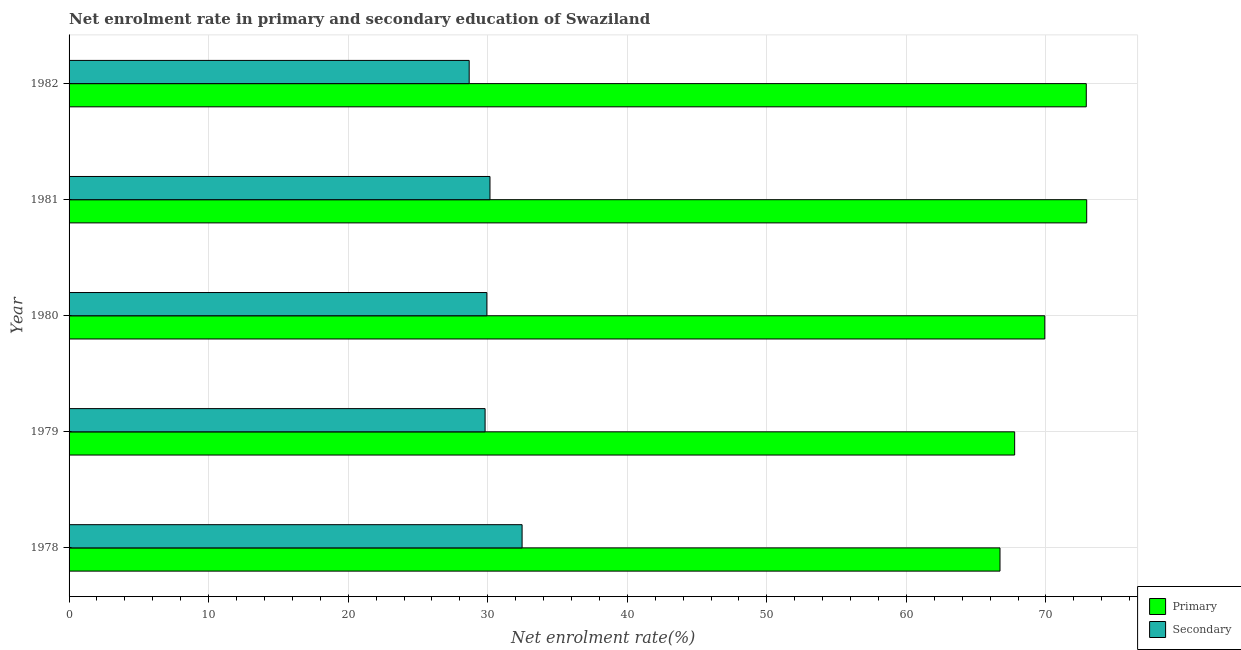Are the number of bars per tick equal to the number of legend labels?
Ensure brevity in your answer.  Yes. How many bars are there on the 5th tick from the top?
Provide a succinct answer. 2. How many bars are there on the 4th tick from the bottom?
Provide a succinct answer. 2. In how many cases, is the number of bars for a given year not equal to the number of legend labels?
Your response must be concise. 0. What is the enrollment rate in secondary education in 1982?
Provide a short and direct response. 28.67. Across all years, what is the maximum enrollment rate in secondary education?
Keep it short and to the point. 32.46. Across all years, what is the minimum enrollment rate in primary education?
Offer a terse response. 66.71. In which year was the enrollment rate in secondary education maximum?
Offer a terse response. 1978. In which year was the enrollment rate in primary education minimum?
Your answer should be very brief. 1978. What is the total enrollment rate in primary education in the graph?
Provide a short and direct response. 350.19. What is the difference between the enrollment rate in primary education in 1978 and that in 1982?
Offer a terse response. -6.18. What is the difference between the enrollment rate in primary education in 1981 and the enrollment rate in secondary education in 1978?
Make the answer very short. 40.46. What is the average enrollment rate in secondary education per year?
Give a very brief answer. 30.21. In the year 1978, what is the difference between the enrollment rate in secondary education and enrollment rate in primary education?
Your answer should be compact. -34.24. In how many years, is the enrollment rate in secondary education greater than 8 %?
Your response must be concise. 5. What is the difference between the highest and the second highest enrollment rate in secondary education?
Keep it short and to the point. 2.3. What is the difference between the highest and the lowest enrollment rate in secondary education?
Provide a succinct answer. 3.79. Is the sum of the enrollment rate in primary education in 1978 and 1979 greater than the maximum enrollment rate in secondary education across all years?
Ensure brevity in your answer.  Yes. What does the 1st bar from the top in 1979 represents?
Offer a terse response. Secondary. What does the 1st bar from the bottom in 1978 represents?
Keep it short and to the point. Primary. How many bars are there?
Keep it short and to the point. 10. Are all the bars in the graph horizontal?
Make the answer very short. Yes. How many years are there in the graph?
Offer a very short reply. 5. Are the values on the major ticks of X-axis written in scientific E-notation?
Your answer should be compact. No. How many legend labels are there?
Ensure brevity in your answer.  2. What is the title of the graph?
Keep it short and to the point. Net enrolment rate in primary and secondary education of Swaziland. Does "Rural Population" appear as one of the legend labels in the graph?
Ensure brevity in your answer.  No. What is the label or title of the X-axis?
Your answer should be compact. Net enrolment rate(%). What is the Net enrolment rate(%) of Primary in 1978?
Make the answer very short. 66.71. What is the Net enrolment rate(%) of Secondary in 1978?
Your answer should be very brief. 32.46. What is the Net enrolment rate(%) in Primary in 1979?
Keep it short and to the point. 67.76. What is the Net enrolment rate(%) of Secondary in 1979?
Provide a short and direct response. 29.81. What is the Net enrolment rate(%) in Primary in 1980?
Your response must be concise. 69.92. What is the Net enrolment rate(%) in Secondary in 1980?
Provide a succinct answer. 29.94. What is the Net enrolment rate(%) in Primary in 1981?
Offer a terse response. 72.92. What is the Net enrolment rate(%) in Secondary in 1981?
Give a very brief answer. 30.16. What is the Net enrolment rate(%) in Primary in 1982?
Give a very brief answer. 72.89. What is the Net enrolment rate(%) in Secondary in 1982?
Ensure brevity in your answer.  28.67. Across all years, what is the maximum Net enrolment rate(%) in Primary?
Keep it short and to the point. 72.92. Across all years, what is the maximum Net enrolment rate(%) of Secondary?
Offer a terse response. 32.46. Across all years, what is the minimum Net enrolment rate(%) in Primary?
Make the answer very short. 66.71. Across all years, what is the minimum Net enrolment rate(%) in Secondary?
Provide a succinct answer. 28.67. What is the total Net enrolment rate(%) of Primary in the graph?
Provide a succinct answer. 350.19. What is the total Net enrolment rate(%) in Secondary in the graph?
Make the answer very short. 151.04. What is the difference between the Net enrolment rate(%) in Primary in 1978 and that in 1979?
Offer a very short reply. -1.05. What is the difference between the Net enrolment rate(%) of Secondary in 1978 and that in 1979?
Make the answer very short. 2.65. What is the difference between the Net enrolment rate(%) in Primary in 1978 and that in 1980?
Ensure brevity in your answer.  -3.21. What is the difference between the Net enrolment rate(%) of Secondary in 1978 and that in 1980?
Offer a terse response. 2.52. What is the difference between the Net enrolment rate(%) of Primary in 1978 and that in 1981?
Offer a terse response. -6.21. What is the difference between the Net enrolment rate(%) of Secondary in 1978 and that in 1981?
Offer a terse response. 2.3. What is the difference between the Net enrolment rate(%) in Primary in 1978 and that in 1982?
Offer a very short reply. -6.18. What is the difference between the Net enrolment rate(%) in Secondary in 1978 and that in 1982?
Your answer should be very brief. 3.79. What is the difference between the Net enrolment rate(%) in Primary in 1979 and that in 1980?
Offer a terse response. -2.16. What is the difference between the Net enrolment rate(%) of Secondary in 1979 and that in 1980?
Provide a succinct answer. -0.13. What is the difference between the Net enrolment rate(%) of Primary in 1979 and that in 1981?
Your answer should be very brief. -5.16. What is the difference between the Net enrolment rate(%) in Secondary in 1979 and that in 1981?
Provide a succinct answer. -0.35. What is the difference between the Net enrolment rate(%) in Primary in 1979 and that in 1982?
Keep it short and to the point. -5.13. What is the difference between the Net enrolment rate(%) of Secondary in 1979 and that in 1982?
Ensure brevity in your answer.  1.14. What is the difference between the Net enrolment rate(%) of Primary in 1980 and that in 1981?
Make the answer very short. -3. What is the difference between the Net enrolment rate(%) of Secondary in 1980 and that in 1981?
Ensure brevity in your answer.  -0.22. What is the difference between the Net enrolment rate(%) of Primary in 1980 and that in 1982?
Your response must be concise. -2.97. What is the difference between the Net enrolment rate(%) in Secondary in 1980 and that in 1982?
Provide a succinct answer. 1.27. What is the difference between the Net enrolment rate(%) of Primary in 1981 and that in 1982?
Offer a terse response. 0.03. What is the difference between the Net enrolment rate(%) in Secondary in 1981 and that in 1982?
Your answer should be compact. 1.49. What is the difference between the Net enrolment rate(%) of Primary in 1978 and the Net enrolment rate(%) of Secondary in 1979?
Provide a short and direct response. 36.9. What is the difference between the Net enrolment rate(%) of Primary in 1978 and the Net enrolment rate(%) of Secondary in 1980?
Your answer should be very brief. 36.77. What is the difference between the Net enrolment rate(%) of Primary in 1978 and the Net enrolment rate(%) of Secondary in 1981?
Give a very brief answer. 36.55. What is the difference between the Net enrolment rate(%) of Primary in 1978 and the Net enrolment rate(%) of Secondary in 1982?
Give a very brief answer. 38.04. What is the difference between the Net enrolment rate(%) of Primary in 1979 and the Net enrolment rate(%) of Secondary in 1980?
Make the answer very short. 37.82. What is the difference between the Net enrolment rate(%) in Primary in 1979 and the Net enrolment rate(%) in Secondary in 1981?
Provide a succinct answer. 37.6. What is the difference between the Net enrolment rate(%) of Primary in 1979 and the Net enrolment rate(%) of Secondary in 1982?
Provide a succinct answer. 39.09. What is the difference between the Net enrolment rate(%) in Primary in 1980 and the Net enrolment rate(%) in Secondary in 1981?
Make the answer very short. 39.76. What is the difference between the Net enrolment rate(%) of Primary in 1980 and the Net enrolment rate(%) of Secondary in 1982?
Provide a succinct answer. 41.25. What is the difference between the Net enrolment rate(%) in Primary in 1981 and the Net enrolment rate(%) in Secondary in 1982?
Ensure brevity in your answer.  44.25. What is the average Net enrolment rate(%) of Primary per year?
Make the answer very short. 70.04. What is the average Net enrolment rate(%) of Secondary per year?
Provide a short and direct response. 30.21. In the year 1978, what is the difference between the Net enrolment rate(%) in Primary and Net enrolment rate(%) in Secondary?
Keep it short and to the point. 34.24. In the year 1979, what is the difference between the Net enrolment rate(%) in Primary and Net enrolment rate(%) in Secondary?
Provide a succinct answer. 37.94. In the year 1980, what is the difference between the Net enrolment rate(%) in Primary and Net enrolment rate(%) in Secondary?
Your response must be concise. 39.98. In the year 1981, what is the difference between the Net enrolment rate(%) of Primary and Net enrolment rate(%) of Secondary?
Ensure brevity in your answer.  42.76. In the year 1982, what is the difference between the Net enrolment rate(%) in Primary and Net enrolment rate(%) in Secondary?
Ensure brevity in your answer.  44.22. What is the ratio of the Net enrolment rate(%) of Primary in 1978 to that in 1979?
Ensure brevity in your answer.  0.98. What is the ratio of the Net enrolment rate(%) in Secondary in 1978 to that in 1979?
Ensure brevity in your answer.  1.09. What is the ratio of the Net enrolment rate(%) in Primary in 1978 to that in 1980?
Make the answer very short. 0.95. What is the ratio of the Net enrolment rate(%) of Secondary in 1978 to that in 1980?
Your answer should be compact. 1.08. What is the ratio of the Net enrolment rate(%) of Primary in 1978 to that in 1981?
Give a very brief answer. 0.91. What is the ratio of the Net enrolment rate(%) in Secondary in 1978 to that in 1981?
Your answer should be very brief. 1.08. What is the ratio of the Net enrolment rate(%) in Primary in 1978 to that in 1982?
Your response must be concise. 0.92. What is the ratio of the Net enrolment rate(%) of Secondary in 1978 to that in 1982?
Provide a succinct answer. 1.13. What is the ratio of the Net enrolment rate(%) of Primary in 1979 to that in 1980?
Ensure brevity in your answer.  0.97. What is the ratio of the Net enrolment rate(%) of Primary in 1979 to that in 1981?
Provide a succinct answer. 0.93. What is the ratio of the Net enrolment rate(%) in Secondary in 1979 to that in 1981?
Your answer should be compact. 0.99. What is the ratio of the Net enrolment rate(%) in Primary in 1979 to that in 1982?
Provide a short and direct response. 0.93. What is the ratio of the Net enrolment rate(%) of Secondary in 1979 to that in 1982?
Ensure brevity in your answer.  1.04. What is the ratio of the Net enrolment rate(%) of Primary in 1980 to that in 1981?
Give a very brief answer. 0.96. What is the ratio of the Net enrolment rate(%) in Secondary in 1980 to that in 1981?
Provide a short and direct response. 0.99. What is the ratio of the Net enrolment rate(%) in Primary in 1980 to that in 1982?
Provide a succinct answer. 0.96. What is the ratio of the Net enrolment rate(%) of Secondary in 1980 to that in 1982?
Ensure brevity in your answer.  1.04. What is the ratio of the Net enrolment rate(%) of Primary in 1981 to that in 1982?
Your answer should be very brief. 1. What is the ratio of the Net enrolment rate(%) in Secondary in 1981 to that in 1982?
Your answer should be compact. 1.05. What is the difference between the highest and the second highest Net enrolment rate(%) of Primary?
Keep it short and to the point. 0.03. What is the difference between the highest and the second highest Net enrolment rate(%) in Secondary?
Your answer should be compact. 2.3. What is the difference between the highest and the lowest Net enrolment rate(%) of Primary?
Offer a terse response. 6.21. What is the difference between the highest and the lowest Net enrolment rate(%) in Secondary?
Your response must be concise. 3.79. 